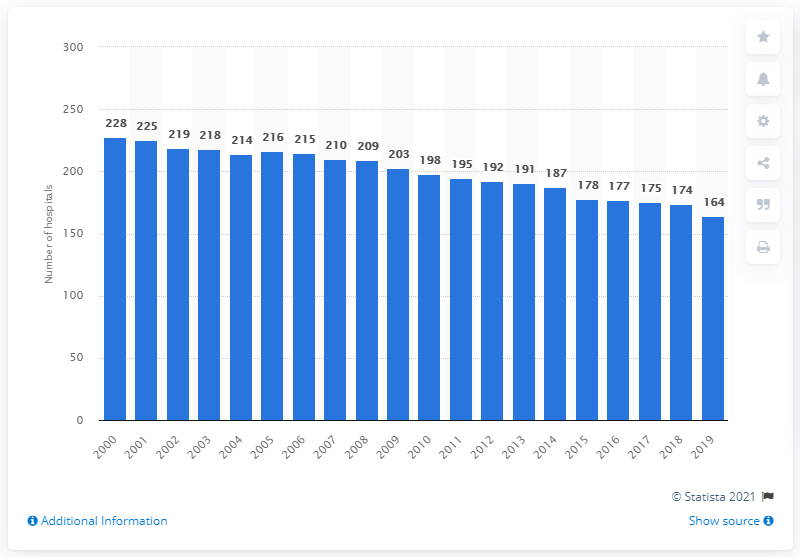Highlight a few significant elements in this photo. There were 164 hospitals in Belgium in 2019. There were 228 hospitals in Belgium in the year 2000. 